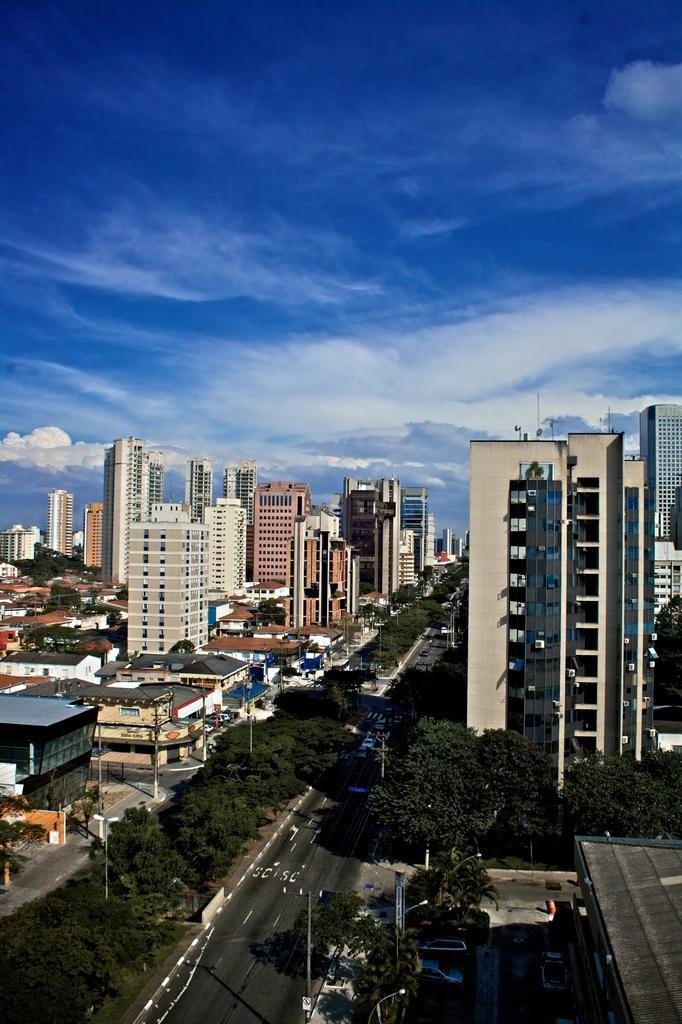How would you summarize this image in a sentence or two? In this image we can see the view of a city, there are some buildings, houses, vehicles, roads, street lights, poles, we can also see some trees, and the sky. 